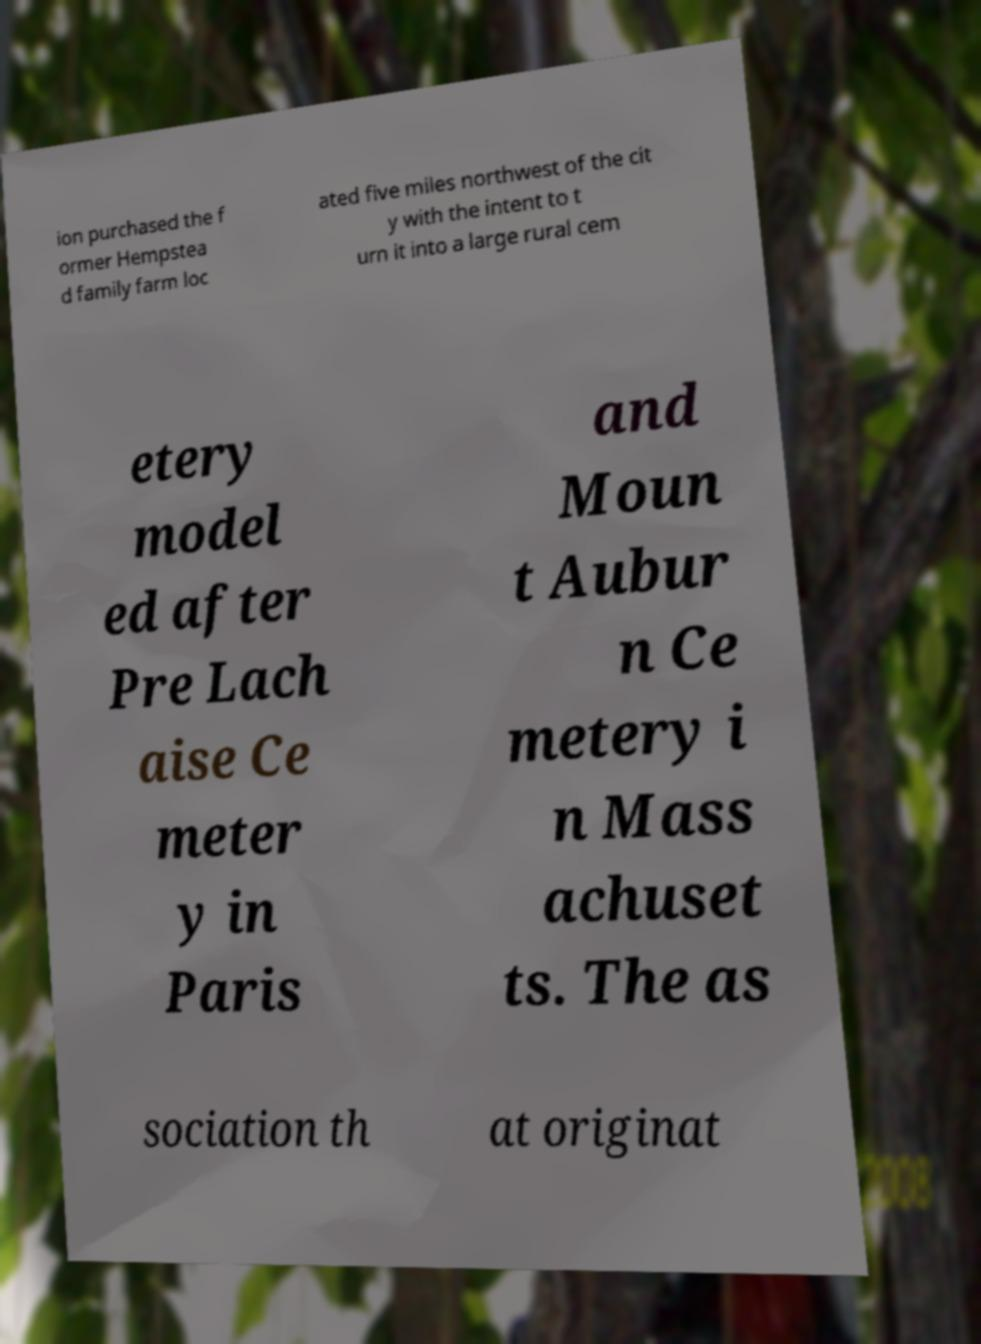Could you extract and type out the text from this image? ion purchased the f ormer Hempstea d family farm loc ated five miles northwest of the cit y with the intent to t urn it into a large rural cem etery model ed after Pre Lach aise Ce meter y in Paris and Moun t Aubur n Ce metery i n Mass achuset ts. The as sociation th at originat 